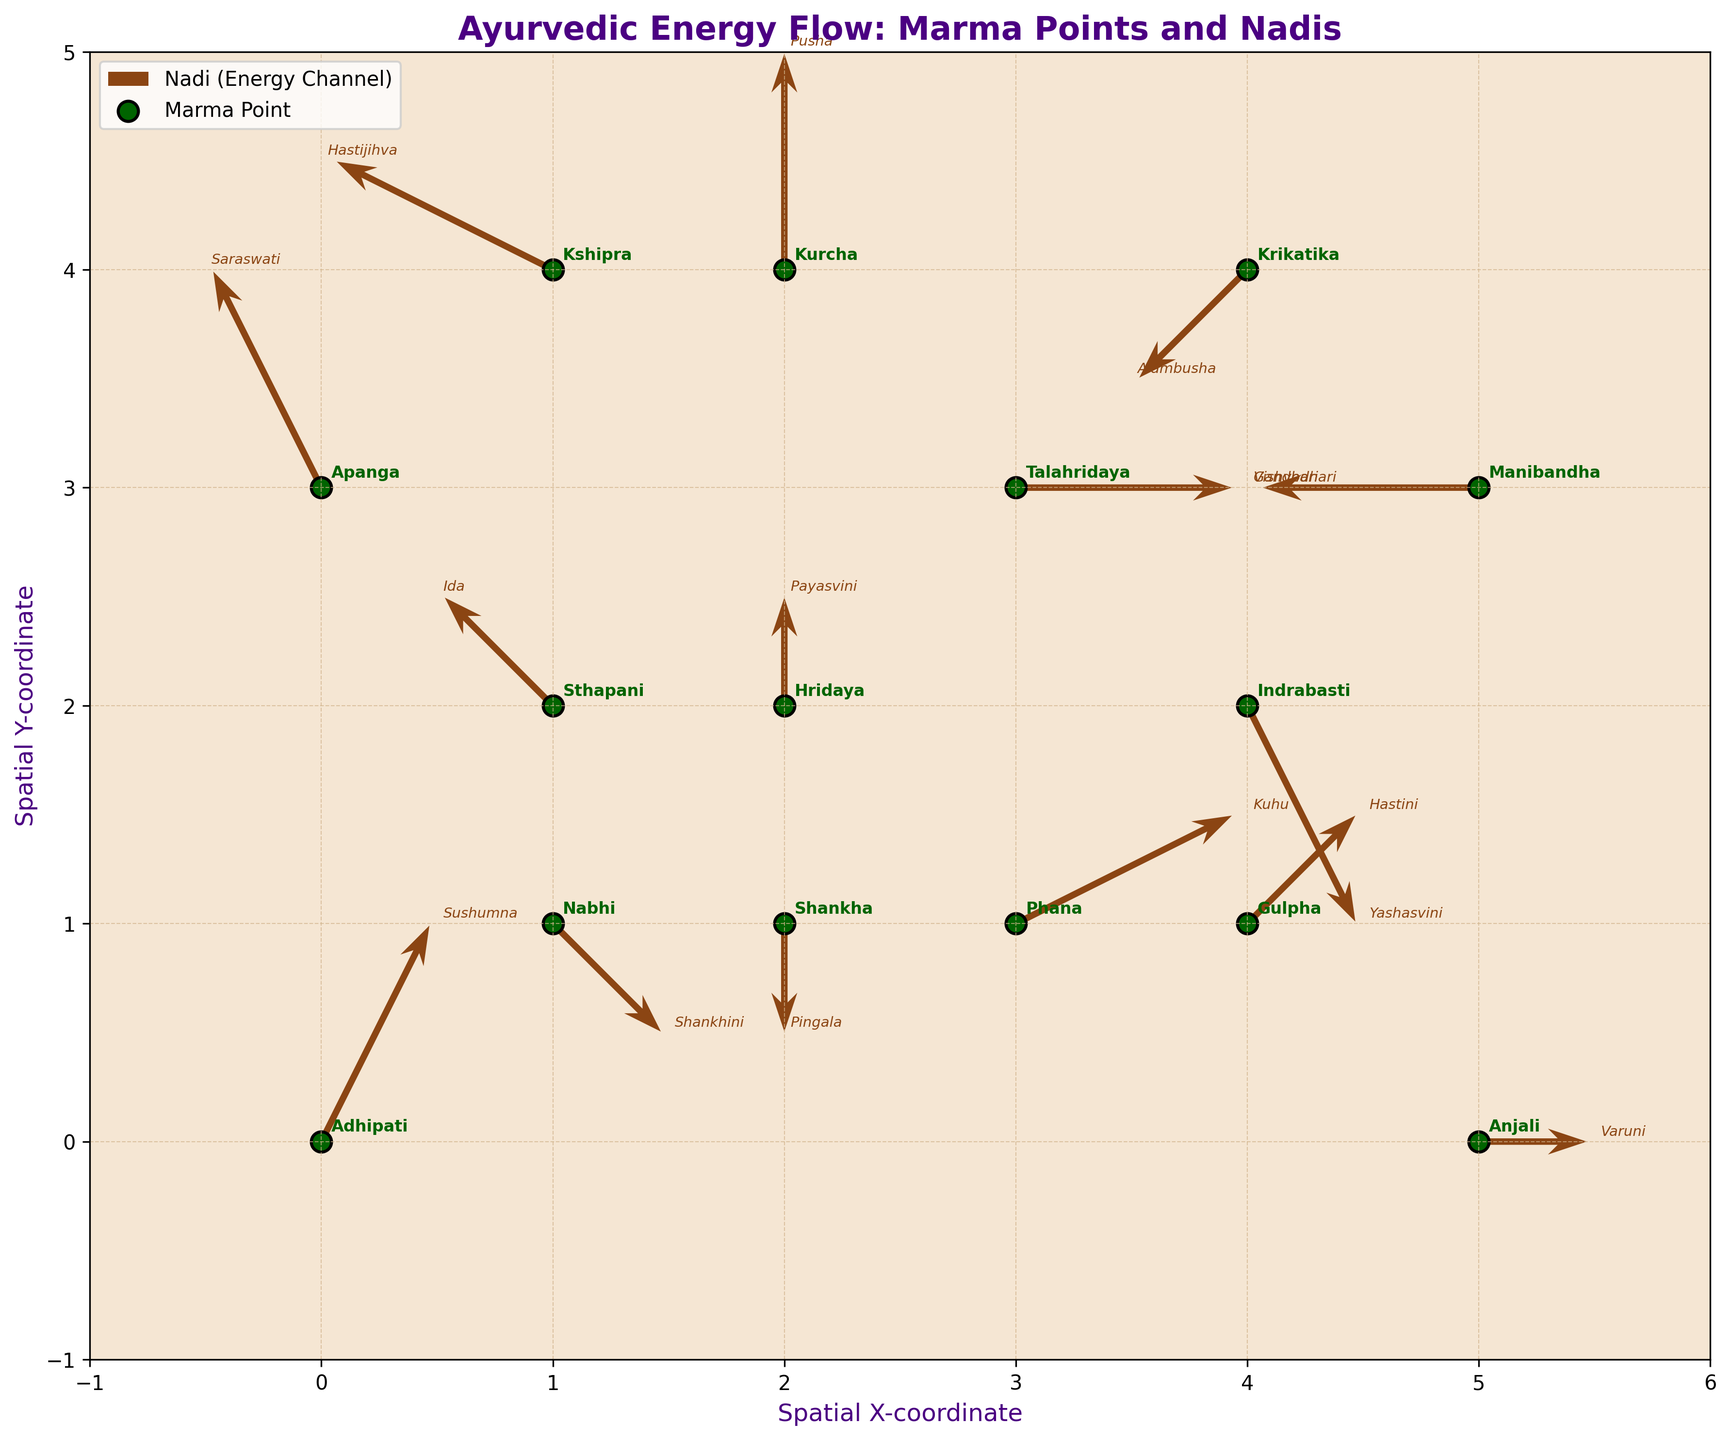Why is the background color set to a light hue? The background color is light (a soft beige) to represent a natural and calming environment, which aligns with Ayurvedic practices focused on balance and tranquility.
Answer: To represent a natural and calming environment Which marma point is labeled at the coordinates (0, 0)? The marma point labeled at the coordinates (0, 0) is 'Adhipati', which is annotated next to the point.
Answer: Adhipati How many marma points are plotted in the figure? By counting the number of marma points labeled in the figure, you can see there are 15 marma points plotted.
Answer: 15 Which marma point corresponds to the vector pointing straight upward? The vector pointing straight upward means u=0 and v=positive value. From the figure, the marma point with coordinates (2, 4) and vector (0, 2) is annotated as 'Kurcha'.
Answer: Kurcha Which marma point is located at the highest y-coordinate? The highest y-coordinate is at y=4. By observing the labels, 'Kshipra', 'Kurcha', and 'Krikatika' are located at y=4. Therefore, all three marma points are at the highest y-coordinate.
Answer: Kshipra, Kurcha, and Krikatika Compare the directions of the 'Nabhi' and 'Gulpha' nadi vectors. Which one has a positive y-direction component? The 'Nabhi' point has a vector (1, -1) indicating a negative y-component, while 'Gulpha' has a vector (1, 1) indicating a positive y-component.
Answer: Gulpha Which marma point has the lowest x-coordinate and what is its corresponding nadi? The lowest x-coordinate is at x=0. The corresponding marma point is 'Adhipati', and its nadi is 'Sushumna'.
Answer: Adhipati, Sushumna What is the resulting coordinate if you follow the 'Talahridaya' nadi vector from its current position? 'Talahridaya' is located at (3, 3), and its vector is (2, 0). Adding these gives (3+2, 3+0), resulting in (5, 3).
Answer: (5, 3) How many nadis end at a vector pointing downward? A downward vector has a negative y-component. From the figure, the nadis at 'Shankha', 'Indrabasti', 'Anjali', and 'Nabhi' all point downward, totaling 4.
Answer: 4 Which two marma points have vectors whose resultant midpoint is the same? The midpoint is calculated by taking the coordinates and adjusting by half of the vector. 'Nabhi' (1, 1) with vector (1, -1) results in the midpoint (1+0.5, 1-0.5) = (1.5, 0.5). 'Hridaya' (2, 2) with vector (0, 1) results in the midpoint (2+0, 2+0.5) = (2, 2.5). Therefore, it's clear from inspection that no two points have the exact same resultant midpoint.
Answer: None 